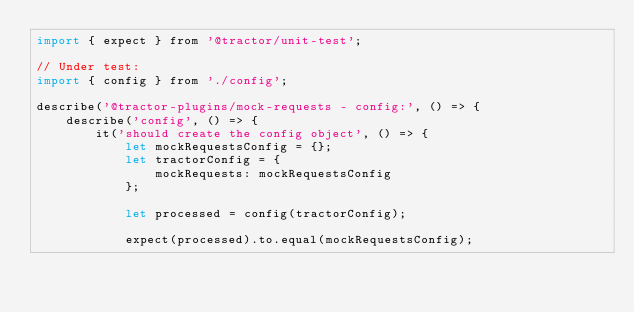<code> <loc_0><loc_0><loc_500><loc_500><_JavaScript_>import { expect } from '@tractor/unit-test';

// Under test:
import { config } from './config';

describe('@tractor-plugins/mock-requests - config:', () => {
    describe('config', () => {
        it('should create the config object', () => {
            let mockRequestsConfig = {};
            let tractorConfig = {
                mockRequests: mockRequestsConfig
            };

            let processed = config(tractorConfig);

            expect(processed).to.equal(mockRequestsConfig);</code> 